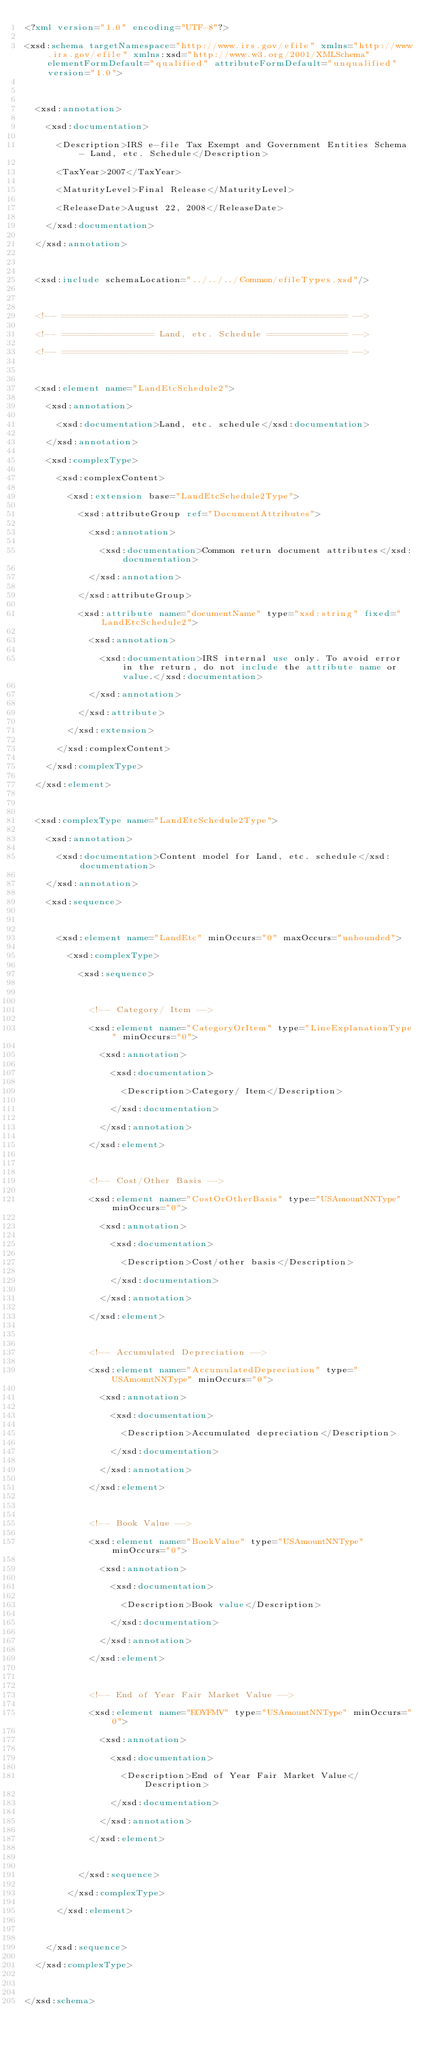<code> <loc_0><loc_0><loc_500><loc_500><_XML_><?xml version="1.0" encoding="UTF-8"?>
<xsd:schema targetNamespace="http://www.irs.gov/efile" xmlns="http://www.irs.gov/efile" xmlns:xsd="http://www.w3.org/2001/XMLSchema" elementFormDefault="qualified" attributeFormDefault="unqualified" version="1.0">

	<xsd:annotation>
		<xsd:documentation>
			<Description>IRS e-file Tax Exempt and Government Entities Schema - Land, etc. Schedule</Description>
			<TaxYear>2007</TaxYear>
			<MaturityLevel>Final Release</MaturityLevel>
			<ReleaseDate>August 22, 2008</ReleaseDate>			
		</xsd:documentation>
	</xsd:annotation>
	
	<xsd:include schemaLocation="../../../Common/efileTypes.xsd"/>
	
	<!-- ===================================================== -->
	<!-- ================= Land, etc. Schedule =============== -->
	<!-- ===================================================== -->
	
	<xsd:element name="LandEtcSchedule2">
		<xsd:annotation>
			<xsd:documentation>Land, etc. schedule</xsd:documentation>
		</xsd:annotation>
		<xsd:complexType>
			<xsd:complexContent>
				<xsd:extension base="LandEtcSchedule2Type">
					<xsd:attributeGroup ref="DocumentAttributes">
						<xsd:annotation>
							<xsd:documentation>Common return document attributes</xsd:documentation>
						</xsd:annotation>
					</xsd:attributeGroup>
					<xsd:attribute name="documentName" type="xsd:string" fixed="LandEtcSchedule2">
						<xsd:annotation>
							<xsd:documentation>IRS internal use only. To avoid error in the return, do not include the attribute name or value.</xsd:documentation>
						</xsd:annotation>
					</xsd:attribute>
				</xsd:extension>
			</xsd:complexContent>
		</xsd:complexType>
	</xsd:element>
	
	<xsd:complexType name="LandEtcSchedule2Type">
		<xsd:annotation>
			<xsd:documentation>Content model for Land, etc. schedule</xsd:documentation>
		</xsd:annotation>
		<xsd:sequence>

			<xsd:element name="LandEtc" minOccurs="0" maxOccurs="unbounded">
				<xsd:complexType>
					<xsd:sequence>

						<!-- Category/ Item -->
						<xsd:element name="CategoryOrItem" type="LineExplanationType" minOccurs="0">
							<xsd:annotation>
								<xsd:documentation>
									<Description>Category/ Item</Description>
								</xsd:documentation>
							</xsd:annotation>
						</xsd:element>
						
						<!-- Cost/Other Basis -->
						<xsd:element name="CostOrOtherBasis" type="USAmountNNType" minOccurs="0">
							<xsd:annotation>
								<xsd:documentation>
									<Description>Cost/other basis</Description>
								</xsd:documentation>
							</xsd:annotation>
						</xsd:element>
						
						<!-- Accumulated Depreciation -->
						<xsd:element name="AccumulatedDepreciation" type="USAmountNNType" minOccurs="0">
							<xsd:annotation>
								<xsd:documentation>
									<Description>Accumulated depreciation</Description>
								</xsd:documentation>
							</xsd:annotation>
						</xsd:element>

						<!-- Book Value -->
						<xsd:element name="BookValue" type="USAmountNNType" minOccurs="0">
							<xsd:annotation>
								<xsd:documentation>
									<Description>Book value</Description>
								</xsd:documentation>
							</xsd:annotation>
						</xsd:element>

						<!-- End of Year Fair Market Value -->
						<xsd:element name="EOYFMV" type="USAmountNNType" minOccurs="0">
							<xsd:annotation>
								<xsd:documentation>
									<Description>End of Year Fair Market Value</Description>
								</xsd:documentation>
							</xsd:annotation>
						</xsd:element>

					</xsd:sequence>
				</xsd:complexType>
			</xsd:element>

		</xsd:sequence>
	</xsd:complexType>
	
</xsd:schema>
</code> 